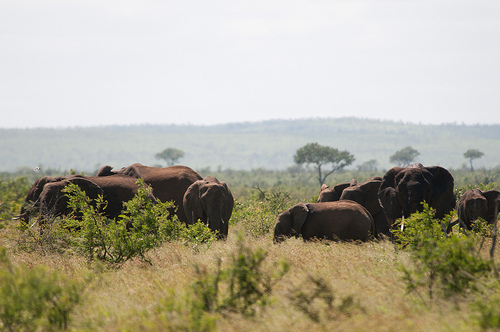Please provide the bounding box coordinate of the region this sentence describes: elephant with white tusks. [0.34, 0.51, 0.51, 0.68] Please provide the bounding box coordinate of the region this sentence describes: A gray cloudy sky. [0.45, 0.19, 0.95, 0.37] Please provide the bounding box coordinate of the region this sentence describes: hazy trees in distance. [0.09, 0.33, 0.86, 0.51] Please provide a short description for this region: [0.45, 0.4, 0.56, 0.47]. This is a mountain. Please provide a short description for this region: [0.54, 0.64, 0.78, 0.75]. Waving dry grass. Please provide the bounding box coordinate of the region this sentence describes: four elephants grazing in Africa. [0.07, 0.45, 0.51, 0.74] Please provide the bounding box coordinate of the region this sentence describes: A tree on the savannah. [0.58, 0.44, 0.71, 0.55] Please provide the bounding box coordinate of the region this sentence describes: A few elephants have ivory tusks in pic. [0.34, 0.51, 0.93, 0.69] Please provide the bounding box coordinate of the region this sentence describes: this is the trunk. [0.42, 0.6, 0.44, 0.63] Please provide the bounding box coordinate of the region this sentence describes: the grass is dry. [0.6, 0.65, 0.64, 0.7] 